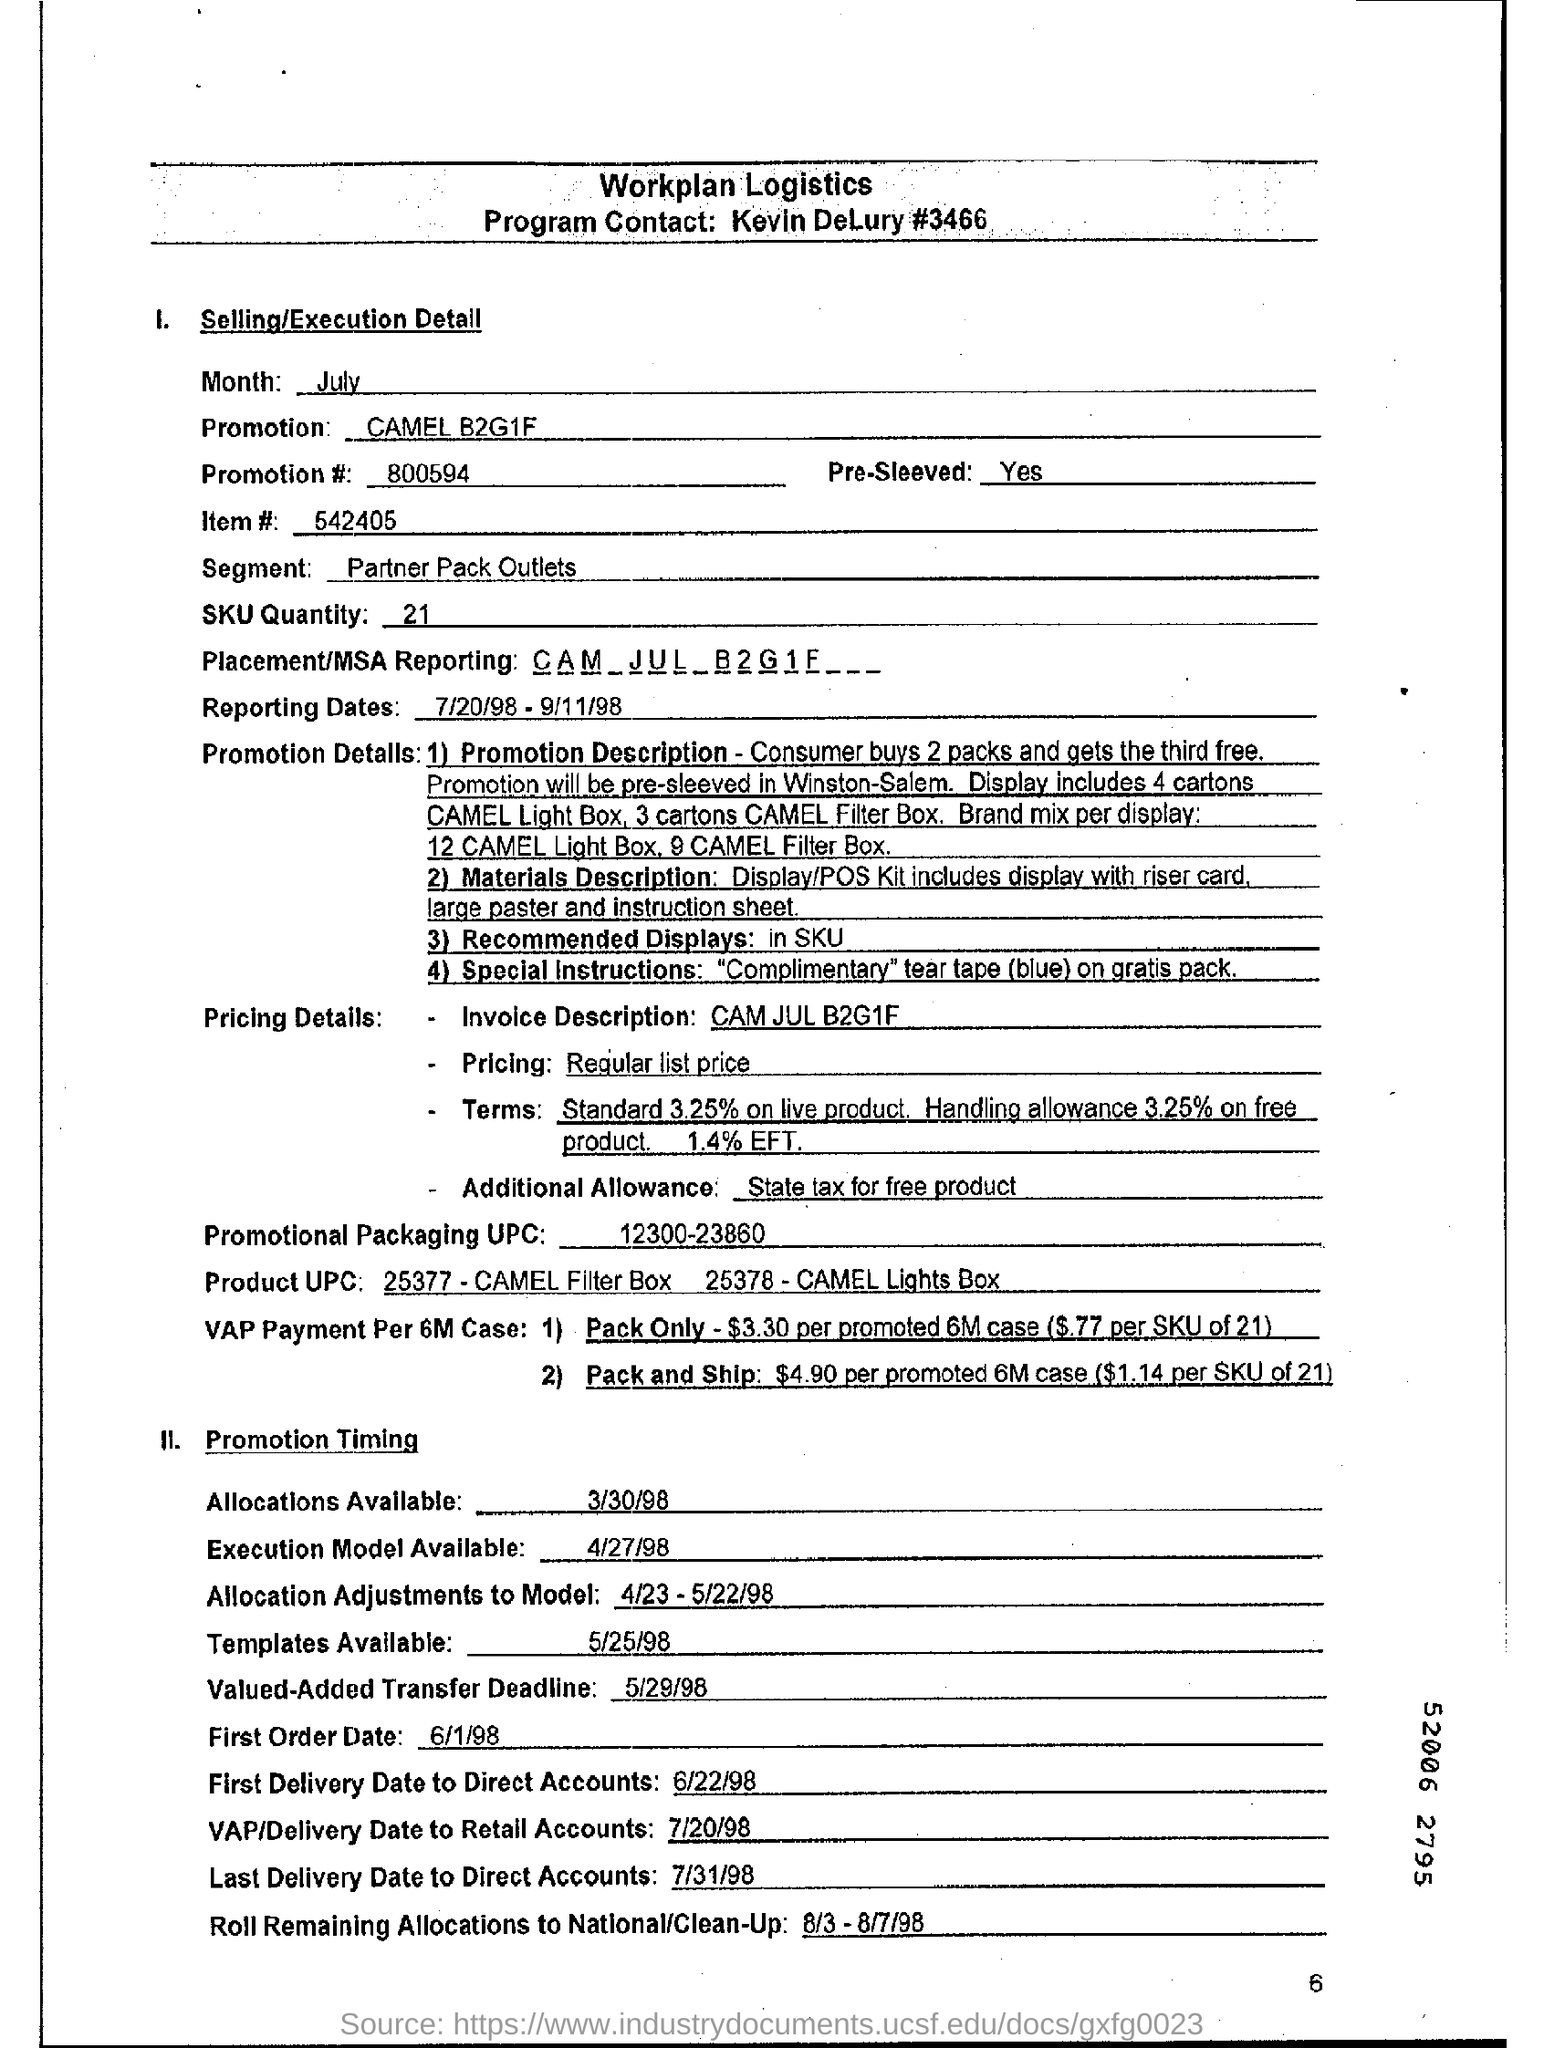Identify some key points in this picture. The promotion being advertised is for a brand known as CAMEL, and it is offering a buy-one-get-one-free deal on a pack that contains four units. The promotion number mentioned in the document is 800594. The person who is in charge of the program is Kevin DeLury and their contact information is #3466. The SKU quantity given is 21. The UPC mentioned in the document is 12300-23860. 